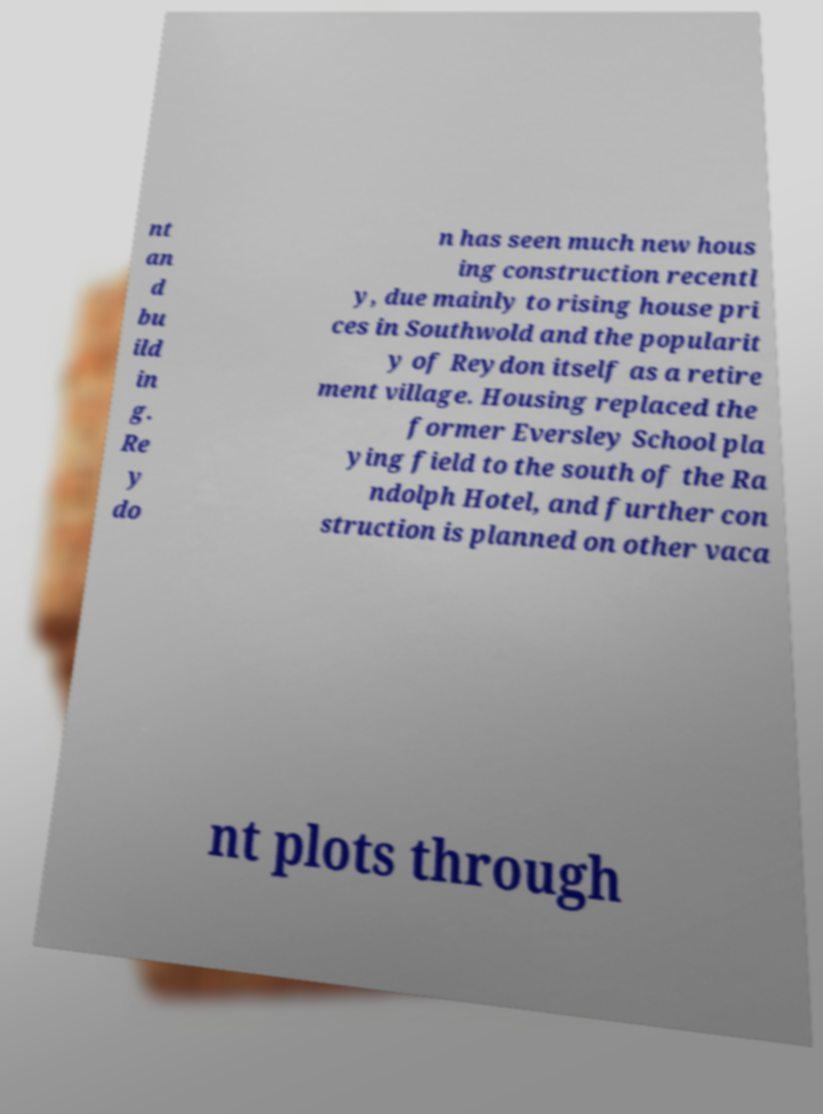Could you assist in decoding the text presented in this image and type it out clearly? nt an d bu ild in g. Re y do n has seen much new hous ing construction recentl y, due mainly to rising house pri ces in Southwold and the popularit y of Reydon itself as a retire ment village. Housing replaced the former Eversley School pla ying field to the south of the Ra ndolph Hotel, and further con struction is planned on other vaca nt plots through 